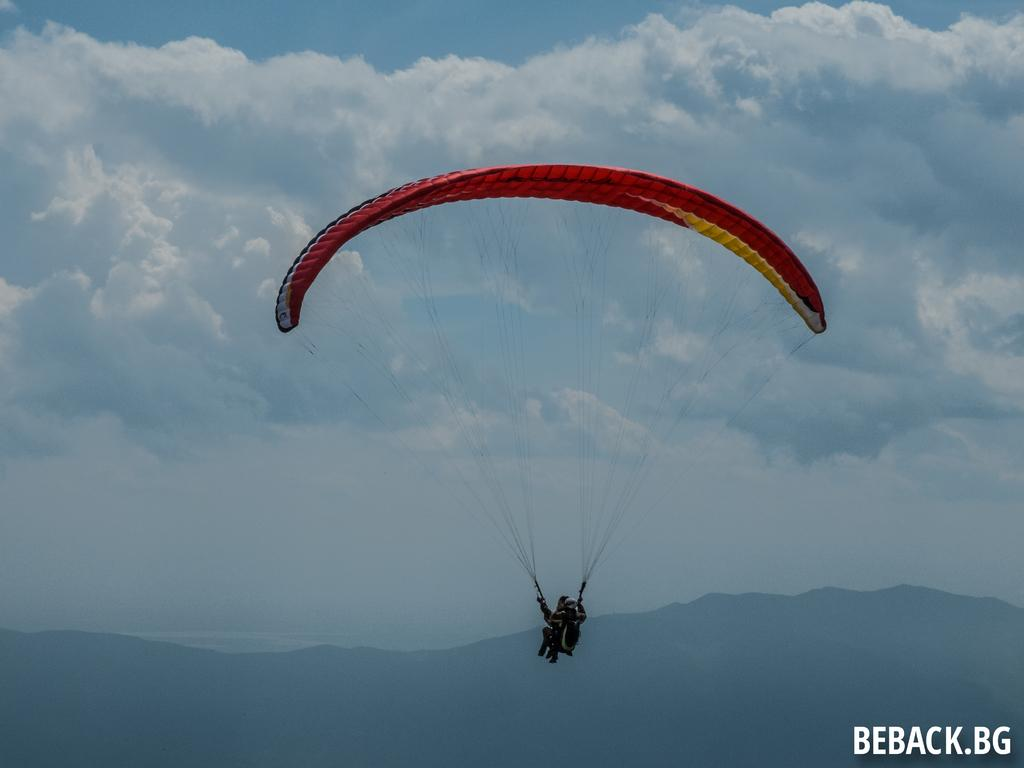What are the two persons in the image doing? The two persons in the image are paragliding. What can be seen in the background of the image? There is a mountain and clouds in the sky visible in the background of the image. What is present at the bottom of the image? There is a watermark at the bottom of the image. What type of record is being played by the paragliders in the image? There is no record present in the image, as the two persons are paragliding and not engaging in any activity related to playing a record. 